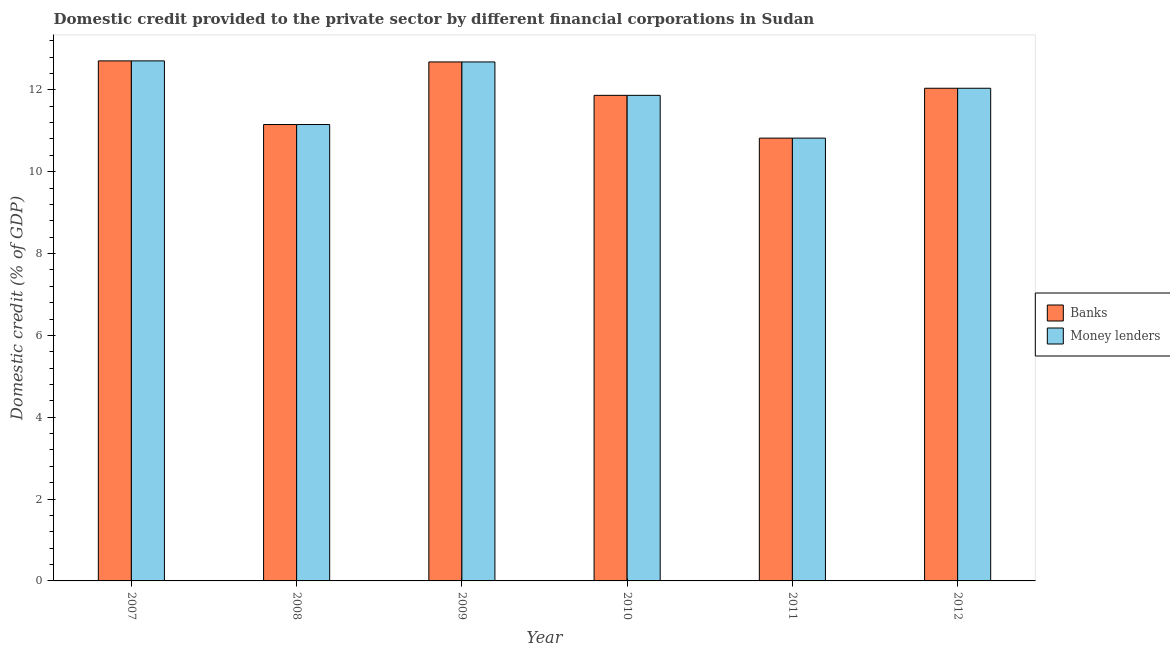How many different coloured bars are there?
Ensure brevity in your answer.  2. How many groups of bars are there?
Make the answer very short. 6. Are the number of bars on each tick of the X-axis equal?
Provide a succinct answer. Yes. How many bars are there on the 2nd tick from the left?
Your answer should be compact. 2. How many bars are there on the 1st tick from the right?
Offer a very short reply. 2. What is the label of the 1st group of bars from the left?
Your answer should be compact. 2007. What is the domestic credit provided by banks in 2011?
Provide a short and direct response. 10.82. Across all years, what is the maximum domestic credit provided by money lenders?
Keep it short and to the point. 12.71. Across all years, what is the minimum domestic credit provided by banks?
Your answer should be compact. 10.82. In which year was the domestic credit provided by money lenders maximum?
Offer a terse response. 2007. In which year was the domestic credit provided by banks minimum?
Your answer should be compact. 2011. What is the total domestic credit provided by banks in the graph?
Ensure brevity in your answer.  71.27. What is the difference between the domestic credit provided by banks in 2008 and that in 2011?
Your response must be concise. 0.33. What is the difference between the domestic credit provided by money lenders in 2010 and the domestic credit provided by banks in 2007?
Ensure brevity in your answer.  -0.84. What is the average domestic credit provided by money lenders per year?
Your answer should be compact. 11.88. In how many years, is the domestic credit provided by banks greater than 8.8 %?
Ensure brevity in your answer.  6. What is the ratio of the domestic credit provided by money lenders in 2008 to that in 2010?
Give a very brief answer. 0.94. What is the difference between the highest and the second highest domestic credit provided by money lenders?
Your answer should be compact. 0.03. What is the difference between the highest and the lowest domestic credit provided by money lenders?
Offer a terse response. 1.89. Is the sum of the domestic credit provided by banks in 2008 and 2009 greater than the maximum domestic credit provided by money lenders across all years?
Your answer should be very brief. Yes. What does the 1st bar from the left in 2011 represents?
Your answer should be very brief. Banks. What does the 2nd bar from the right in 2012 represents?
Your response must be concise. Banks. Are all the bars in the graph horizontal?
Provide a short and direct response. No. How many years are there in the graph?
Your answer should be compact. 6. Are the values on the major ticks of Y-axis written in scientific E-notation?
Make the answer very short. No. Does the graph contain any zero values?
Ensure brevity in your answer.  No. Does the graph contain grids?
Provide a short and direct response. No. What is the title of the graph?
Provide a succinct answer. Domestic credit provided to the private sector by different financial corporations in Sudan. What is the label or title of the X-axis?
Your response must be concise. Year. What is the label or title of the Y-axis?
Your response must be concise. Domestic credit (% of GDP). What is the Domestic credit (% of GDP) of Banks in 2007?
Your answer should be compact. 12.71. What is the Domestic credit (% of GDP) of Money lenders in 2007?
Your answer should be compact. 12.71. What is the Domestic credit (% of GDP) in Banks in 2008?
Provide a short and direct response. 11.15. What is the Domestic credit (% of GDP) of Money lenders in 2008?
Ensure brevity in your answer.  11.15. What is the Domestic credit (% of GDP) in Banks in 2009?
Ensure brevity in your answer.  12.68. What is the Domestic credit (% of GDP) in Money lenders in 2009?
Give a very brief answer. 12.68. What is the Domestic credit (% of GDP) of Banks in 2010?
Offer a terse response. 11.87. What is the Domestic credit (% of GDP) in Money lenders in 2010?
Your answer should be compact. 11.87. What is the Domestic credit (% of GDP) of Banks in 2011?
Provide a succinct answer. 10.82. What is the Domestic credit (% of GDP) in Money lenders in 2011?
Offer a terse response. 10.82. What is the Domestic credit (% of GDP) in Banks in 2012?
Offer a very short reply. 12.04. What is the Domestic credit (% of GDP) in Money lenders in 2012?
Offer a very short reply. 12.04. Across all years, what is the maximum Domestic credit (% of GDP) in Banks?
Provide a short and direct response. 12.71. Across all years, what is the maximum Domestic credit (% of GDP) of Money lenders?
Your answer should be very brief. 12.71. Across all years, what is the minimum Domestic credit (% of GDP) of Banks?
Provide a succinct answer. 10.82. Across all years, what is the minimum Domestic credit (% of GDP) of Money lenders?
Provide a short and direct response. 10.82. What is the total Domestic credit (% of GDP) of Banks in the graph?
Provide a short and direct response. 71.27. What is the total Domestic credit (% of GDP) of Money lenders in the graph?
Keep it short and to the point. 71.27. What is the difference between the Domestic credit (% of GDP) in Banks in 2007 and that in 2008?
Make the answer very short. 1.56. What is the difference between the Domestic credit (% of GDP) of Money lenders in 2007 and that in 2008?
Your answer should be compact. 1.56. What is the difference between the Domestic credit (% of GDP) of Banks in 2007 and that in 2009?
Offer a terse response. 0.03. What is the difference between the Domestic credit (% of GDP) in Money lenders in 2007 and that in 2009?
Provide a short and direct response. 0.03. What is the difference between the Domestic credit (% of GDP) in Banks in 2007 and that in 2010?
Your response must be concise. 0.84. What is the difference between the Domestic credit (% of GDP) in Money lenders in 2007 and that in 2010?
Provide a succinct answer. 0.84. What is the difference between the Domestic credit (% of GDP) in Banks in 2007 and that in 2011?
Keep it short and to the point. 1.89. What is the difference between the Domestic credit (% of GDP) of Money lenders in 2007 and that in 2011?
Ensure brevity in your answer.  1.89. What is the difference between the Domestic credit (% of GDP) of Banks in 2007 and that in 2012?
Your answer should be very brief. 0.67. What is the difference between the Domestic credit (% of GDP) of Money lenders in 2007 and that in 2012?
Give a very brief answer. 0.67. What is the difference between the Domestic credit (% of GDP) in Banks in 2008 and that in 2009?
Offer a very short reply. -1.53. What is the difference between the Domestic credit (% of GDP) of Money lenders in 2008 and that in 2009?
Give a very brief answer. -1.53. What is the difference between the Domestic credit (% of GDP) in Banks in 2008 and that in 2010?
Ensure brevity in your answer.  -0.71. What is the difference between the Domestic credit (% of GDP) in Money lenders in 2008 and that in 2010?
Offer a terse response. -0.71. What is the difference between the Domestic credit (% of GDP) of Banks in 2008 and that in 2011?
Make the answer very short. 0.33. What is the difference between the Domestic credit (% of GDP) of Money lenders in 2008 and that in 2011?
Your response must be concise. 0.33. What is the difference between the Domestic credit (% of GDP) of Banks in 2008 and that in 2012?
Your response must be concise. -0.89. What is the difference between the Domestic credit (% of GDP) of Money lenders in 2008 and that in 2012?
Your response must be concise. -0.89. What is the difference between the Domestic credit (% of GDP) of Banks in 2009 and that in 2010?
Keep it short and to the point. 0.82. What is the difference between the Domestic credit (% of GDP) of Money lenders in 2009 and that in 2010?
Provide a succinct answer. 0.82. What is the difference between the Domestic credit (% of GDP) in Banks in 2009 and that in 2011?
Give a very brief answer. 1.86. What is the difference between the Domestic credit (% of GDP) in Money lenders in 2009 and that in 2011?
Provide a succinct answer. 1.86. What is the difference between the Domestic credit (% of GDP) in Banks in 2009 and that in 2012?
Provide a succinct answer. 0.64. What is the difference between the Domestic credit (% of GDP) in Money lenders in 2009 and that in 2012?
Your response must be concise. 0.64. What is the difference between the Domestic credit (% of GDP) in Banks in 2010 and that in 2011?
Offer a very short reply. 1.04. What is the difference between the Domestic credit (% of GDP) in Money lenders in 2010 and that in 2011?
Ensure brevity in your answer.  1.04. What is the difference between the Domestic credit (% of GDP) of Banks in 2010 and that in 2012?
Ensure brevity in your answer.  -0.17. What is the difference between the Domestic credit (% of GDP) in Money lenders in 2010 and that in 2012?
Provide a short and direct response. -0.17. What is the difference between the Domestic credit (% of GDP) of Banks in 2011 and that in 2012?
Offer a terse response. -1.22. What is the difference between the Domestic credit (% of GDP) in Money lenders in 2011 and that in 2012?
Make the answer very short. -1.22. What is the difference between the Domestic credit (% of GDP) in Banks in 2007 and the Domestic credit (% of GDP) in Money lenders in 2008?
Provide a short and direct response. 1.56. What is the difference between the Domestic credit (% of GDP) of Banks in 2007 and the Domestic credit (% of GDP) of Money lenders in 2009?
Ensure brevity in your answer.  0.03. What is the difference between the Domestic credit (% of GDP) of Banks in 2007 and the Domestic credit (% of GDP) of Money lenders in 2010?
Ensure brevity in your answer.  0.84. What is the difference between the Domestic credit (% of GDP) of Banks in 2007 and the Domestic credit (% of GDP) of Money lenders in 2011?
Your answer should be very brief. 1.89. What is the difference between the Domestic credit (% of GDP) in Banks in 2007 and the Domestic credit (% of GDP) in Money lenders in 2012?
Ensure brevity in your answer.  0.67. What is the difference between the Domestic credit (% of GDP) in Banks in 2008 and the Domestic credit (% of GDP) in Money lenders in 2009?
Provide a short and direct response. -1.53. What is the difference between the Domestic credit (% of GDP) of Banks in 2008 and the Domestic credit (% of GDP) of Money lenders in 2010?
Your answer should be compact. -0.71. What is the difference between the Domestic credit (% of GDP) in Banks in 2008 and the Domestic credit (% of GDP) in Money lenders in 2011?
Keep it short and to the point. 0.33. What is the difference between the Domestic credit (% of GDP) of Banks in 2008 and the Domestic credit (% of GDP) of Money lenders in 2012?
Your answer should be compact. -0.89. What is the difference between the Domestic credit (% of GDP) in Banks in 2009 and the Domestic credit (% of GDP) in Money lenders in 2010?
Provide a short and direct response. 0.82. What is the difference between the Domestic credit (% of GDP) in Banks in 2009 and the Domestic credit (% of GDP) in Money lenders in 2011?
Offer a terse response. 1.86. What is the difference between the Domestic credit (% of GDP) of Banks in 2009 and the Domestic credit (% of GDP) of Money lenders in 2012?
Your answer should be compact. 0.64. What is the difference between the Domestic credit (% of GDP) of Banks in 2010 and the Domestic credit (% of GDP) of Money lenders in 2011?
Provide a short and direct response. 1.04. What is the difference between the Domestic credit (% of GDP) in Banks in 2010 and the Domestic credit (% of GDP) in Money lenders in 2012?
Your answer should be very brief. -0.17. What is the difference between the Domestic credit (% of GDP) in Banks in 2011 and the Domestic credit (% of GDP) in Money lenders in 2012?
Your response must be concise. -1.22. What is the average Domestic credit (% of GDP) in Banks per year?
Offer a terse response. 11.88. What is the average Domestic credit (% of GDP) of Money lenders per year?
Keep it short and to the point. 11.88. In the year 2010, what is the difference between the Domestic credit (% of GDP) of Banks and Domestic credit (% of GDP) of Money lenders?
Offer a very short reply. 0. What is the ratio of the Domestic credit (% of GDP) of Banks in 2007 to that in 2008?
Ensure brevity in your answer.  1.14. What is the ratio of the Domestic credit (% of GDP) in Money lenders in 2007 to that in 2008?
Provide a succinct answer. 1.14. What is the ratio of the Domestic credit (% of GDP) of Money lenders in 2007 to that in 2009?
Provide a short and direct response. 1. What is the ratio of the Domestic credit (% of GDP) of Banks in 2007 to that in 2010?
Make the answer very short. 1.07. What is the ratio of the Domestic credit (% of GDP) of Money lenders in 2007 to that in 2010?
Your answer should be compact. 1.07. What is the ratio of the Domestic credit (% of GDP) of Banks in 2007 to that in 2011?
Your answer should be compact. 1.17. What is the ratio of the Domestic credit (% of GDP) in Money lenders in 2007 to that in 2011?
Ensure brevity in your answer.  1.17. What is the ratio of the Domestic credit (% of GDP) in Banks in 2007 to that in 2012?
Give a very brief answer. 1.06. What is the ratio of the Domestic credit (% of GDP) of Money lenders in 2007 to that in 2012?
Ensure brevity in your answer.  1.06. What is the ratio of the Domestic credit (% of GDP) of Banks in 2008 to that in 2009?
Keep it short and to the point. 0.88. What is the ratio of the Domestic credit (% of GDP) in Money lenders in 2008 to that in 2009?
Provide a short and direct response. 0.88. What is the ratio of the Domestic credit (% of GDP) of Banks in 2008 to that in 2010?
Make the answer very short. 0.94. What is the ratio of the Domestic credit (% of GDP) of Money lenders in 2008 to that in 2010?
Ensure brevity in your answer.  0.94. What is the ratio of the Domestic credit (% of GDP) of Banks in 2008 to that in 2011?
Your answer should be very brief. 1.03. What is the ratio of the Domestic credit (% of GDP) in Money lenders in 2008 to that in 2011?
Offer a terse response. 1.03. What is the ratio of the Domestic credit (% of GDP) of Banks in 2008 to that in 2012?
Your answer should be compact. 0.93. What is the ratio of the Domestic credit (% of GDP) in Money lenders in 2008 to that in 2012?
Your answer should be compact. 0.93. What is the ratio of the Domestic credit (% of GDP) of Banks in 2009 to that in 2010?
Provide a succinct answer. 1.07. What is the ratio of the Domestic credit (% of GDP) in Money lenders in 2009 to that in 2010?
Give a very brief answer. 1.07. What is the ratio of the Domestic credit (% of GDP) in Banks in 2009 to that in 2011?
Ensure brevity in your answer.  1.17. What is the ratio of the Domestic credit (% of GDP) in Money lenders in 2009 to that in 2011?
Your answer should be compact. 1.17. What is the ratio of the Domestic credit (% of GDP) of Banks in 2009 to that in 2012?
Make the answer very short. 1.05. What is the ratio of the Domestic credit (% of GDP) in Money lenders in 2009 to that in 2012?
Provide a succinct answer. 1.05. What is the ratio of the Domestic credit (% of GDP) of Banks in 2010 to that in 2011?
Ensure brevity in your answer.  1.1. What is the ratio of the Domestic credit (% of GDP) in Money lenders in 2010 to that in 2011?
Ensure brevity in your answer.  1.1. What is the ratio of the Domestic credit (% of GDP) of Banks in 2010 to that in 2012?
Offer a terse response. 0.99. What is the ratio of the Domestic credit (% of GDP) of Money lenders in 2010 to that in 2012?
Provide a succinct answer. 0.99. What is the ratio of the Domestic credit (% of GDP) of Banks in 2011 to that in 2012?
Keep it short and to the point. 0.9. What is the ratio of the Domestic credit (% of GDP) in Money lenders in 2011 to that in 2012?
Offer a very short reply. 0.9. What is the difference between the highest and the second highest Domestic credit (% of GDP) in Banks?
Offer a very short reply. 0.03. What is the difference between the highest and the second highest Domestic credit (% of GDP) of Money lenders?
Provide a succinct answer. 0.03. What is the difference between the highest and the lowest Domestic credit (% of GDP) in Banks?
Your answer should be very brief. 1.89. What is the difference between the highest and the lowest Domestic credit (% of GDP) in Money lenders?
Your answer should be very brief. 1.89. 